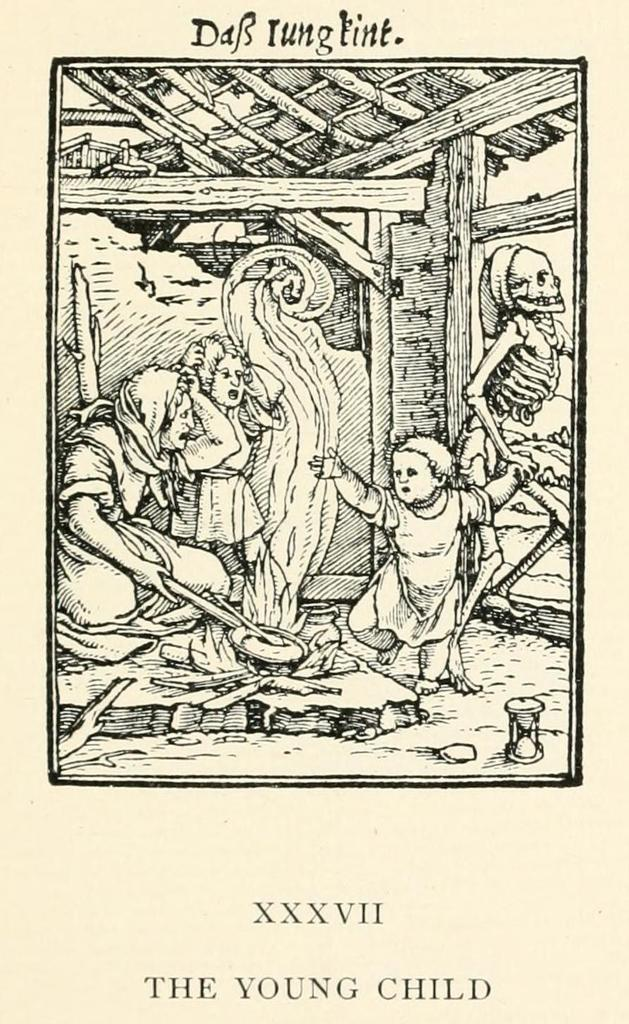What type of artwork is depicted in the image? The image is a sketch. Where is the woman located in the image? The woman is on the left side of the image. What is the woman doing in the image? The woman is cooking on the fire. Can you describe the other person in the image? There is a little girl in the image, and she is standing. What sound does the bell make in the image? There is no bell present in the image. How many bubbles can be seen around the little girl in the image? There are no bubbles present in the image. 